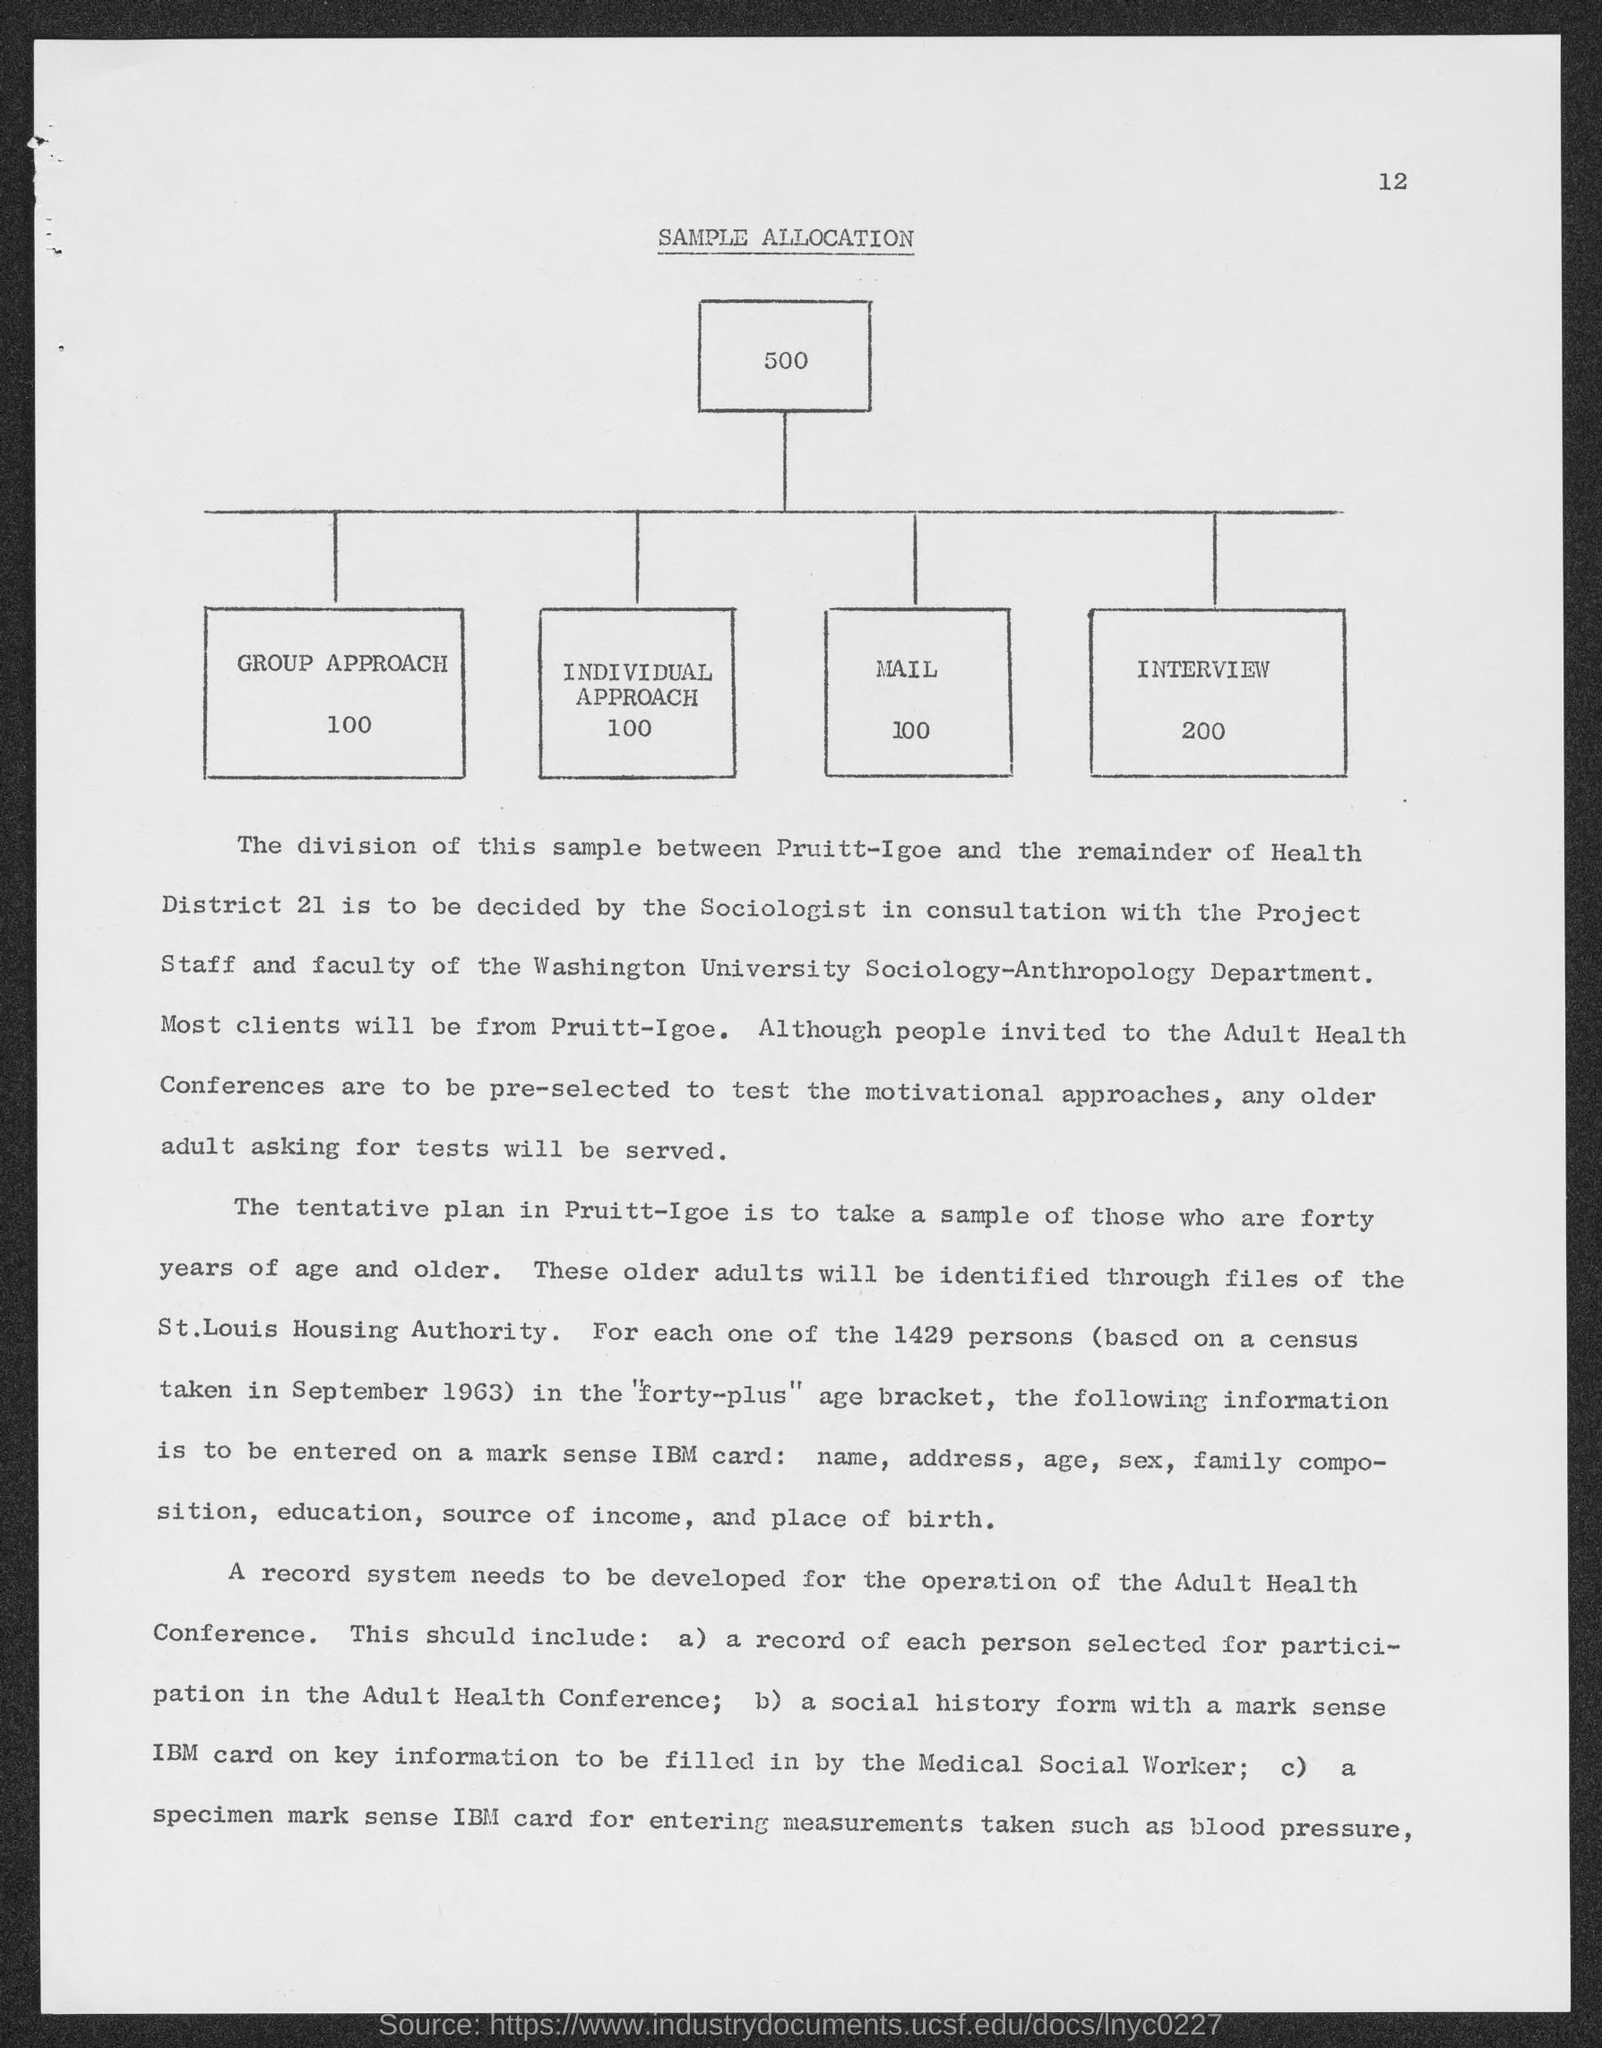What is the title of the document?
Your response must be concise. Sample Allocation. What is the page number?
Offer a very short reply. 12. What is the number of group approaches?
Your answer should be compact. 100. What is the number of individual approaches?
Your answer should be very brief. 100. What is the number of interviews?
Make the answer very short. 200. 